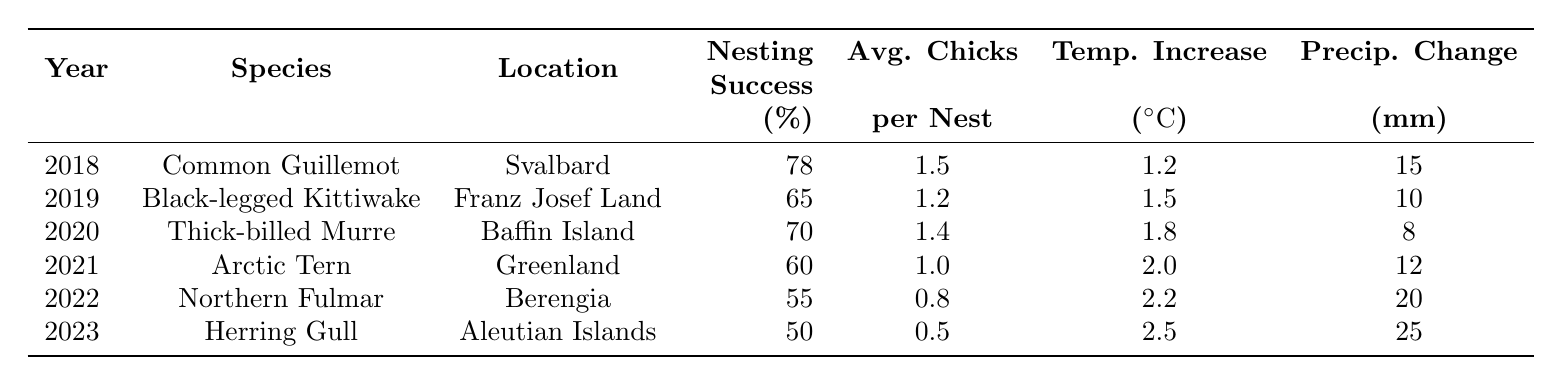What was the nesting success percentage of the Arctic Tern in 2021? Looking at the row for the year 2021, under the "Nesting Success (%)" column, we find the value for the Arctic Tern is 60.
Answer: 60 Which species had the highest average chicks per nest? By comparing the "Average Chicks per Nest" values across all species, the Common Guillemot with 1.5 chicks per nest is the highest.
Answer: Common Guillemot What is the total temperature increase across all the years listed? Adding the temperature increases: 1.2 + 1.5 + 1.8 + 2.0 + 2.2 + 2.5 gives a total of 11.2 °C.
Answer: 11.2 °C Did the Herring Gull have a nesting success percentage higher than 55%? The nesting success percentage for the Herring Gull is 50%, which is not higher than 55%. Therefore, the answer is no.
Answer: No What was the effect of temperature increase on nesting success for the years 2021 and 2022? In 2021, the temperature increase was 2.0 °C and nesting success was 60%. In 2022, the temperature increased to 2.2 °C while nesting success declined to 55%. This indicates a negative correlation between temperature increase and nesting success between these two years.
Answer: Negative correlation What was the average nesting success percentage for the species listed from 2018 to 2023? Adding the nesting successes: 78 + 65 + 70 + 60 + 55 + 50 gives 408; dividing by 6 provides an average of 68%.
Answer: 68% Which location had the lowest average chicks per nest? By checking the "Average Chicks per Nest" column, the Herring Gull from Aleutian Islands had the lowest with 0.5 chicks per nest.
Answer: Aleutian Islands What relationship can be inferred between precipitation change and nesting success from the data? Observing the data, as precipitation changes increase (10 mm to 25 mm), nesting success decreases from 65% (Black-legged Kittiwake) to 50% (Herring Gull). This suggests a possible negative relationship.
Answer: Possible negative relationship What is the difference in nesting success percentage between 2018 and 2023? The nesting success in 2018 was 78%, and in 2023 it was 50%. Therefore, the difference is 78 - 50 = 28%.
Answer: 28% 